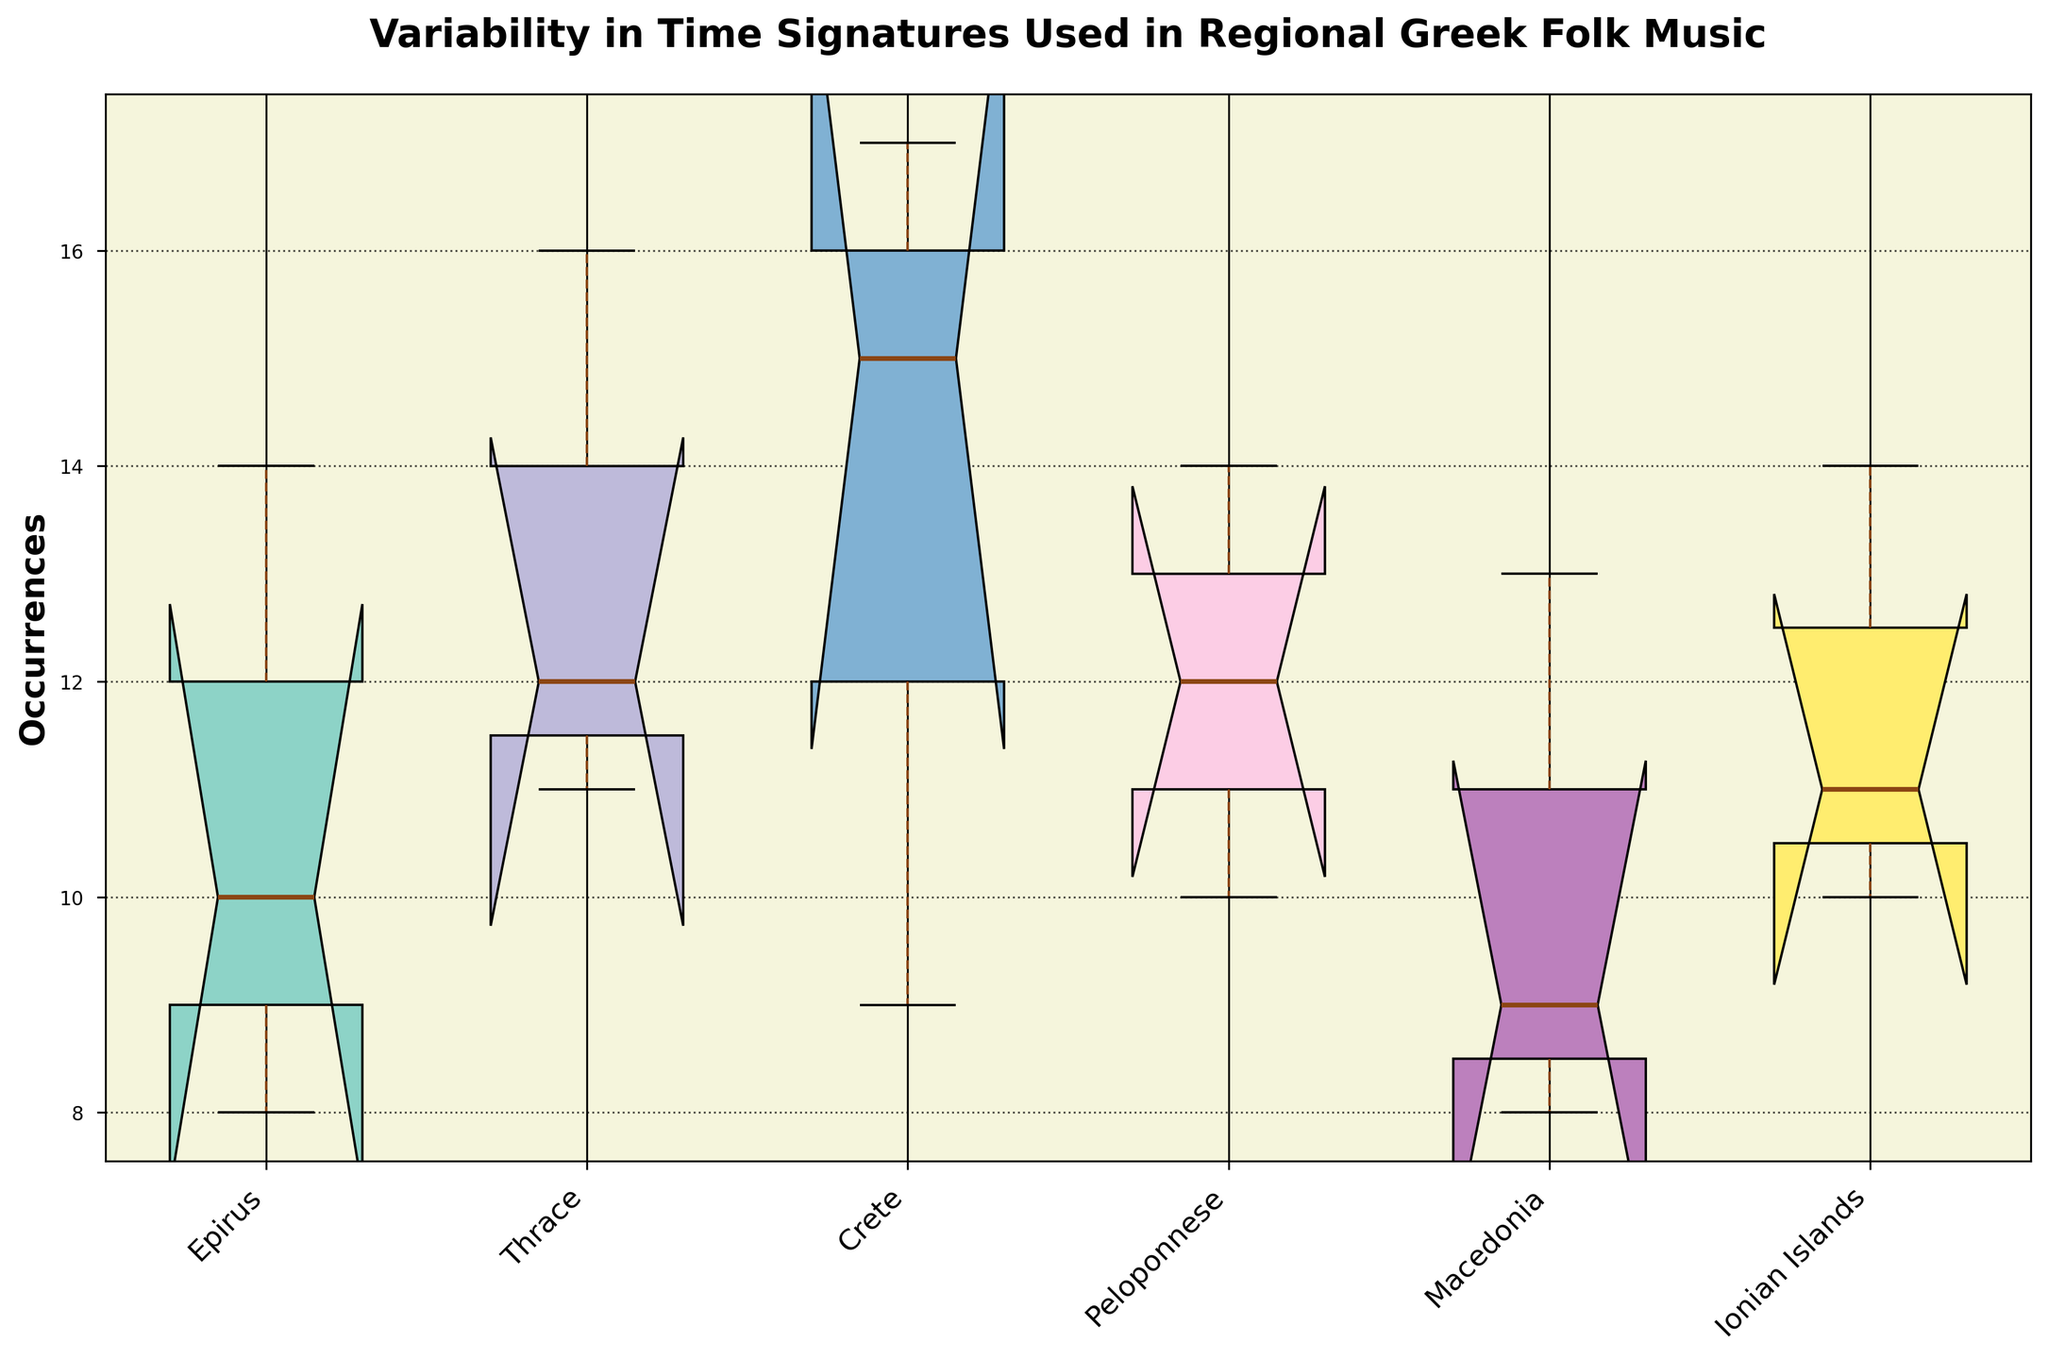What is the title of the plot? The title of the plot is located at the top of the figure and describes the content of the visual representation. It is meant to summarize what the plot is about.
Answer: Variability in Time Signatures Used in Regional Greek Folk Music Which region has the widest interquartile range (IQR) in its occurrences? The IQR can be observed as the height of the colored box in each region's box plot. The region with the widest (tallest) box has the largest IQR.
Answer: Crete What is the median occurrence for the Thrace region? The median occurrence is indicated by the central line inside the box for the Thrace region. It divides the data into two equal halves.
Answer: 12 Which region has the smallest variability in its time signatures? The region with the narrowest (shortest) boxes has the smallest variability. Compare the height of the boxes for each region.
Answer: Macedonia List all the regions where the notch in the box plot overlaps with the median of the Epirus region. The notches indicate the confidence interval around the median. Check if the notch for any region intersects with or overlaps the notch of Epirus's box plot.
Answer: Ionian Islands Which region has the largest range of occurrences? The range is the difference between the highest and lowest points in the whiskers of the box plots. Compare the lengths of the full whiskers.
Answer: Peloponnese What is the occurrence range for the Ionian Islands region? The range can be found by subtracting the minimum value (bottom whisker) from the maximum value (top whisker) in the Ionian Islands box plot.
Answer: 14 - 10 = 4 Which region's median is closest to an occurrence of 9? Observe the central lines in the boxes for each region and find the one nearest to the 9th occurrence mark.
Answer: Macedonia How do the peak occurrences in Epirus and Peloponnese compare? Compare the length of the whiskers and the height of the boxes for Epirus and Peloponnese regions to assess their peak occurrences.
Answer: Peloponnese has a higher peak occurrence Which regions have overlapping interquartile ranges (IQR)? Look for regions where the colored boxes overlap each other vertically, indicating a similar spread of the middle 50% of the data.
Answer: Epirus and Thrace 